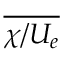<formula> <loc_0><loc_0><loc_500><loc_500>\overline { { \chi / U _ { e } } }</formula> 